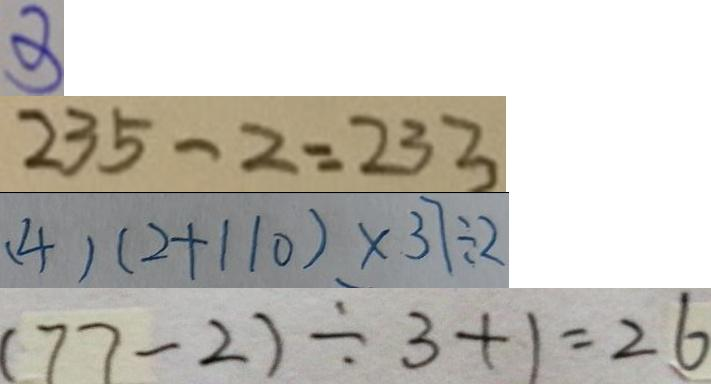<formula> <loc_0><loc_0><loc_500><loc_500>3 
 2 3 5 - 2 = 2 3 3 
 ( 4 ) ( 2 + 1 1 0 ) \times 3 7 \div 2 
 ( 7 7 - 2 ) \div 3 + 1 = 2 6</formula> 